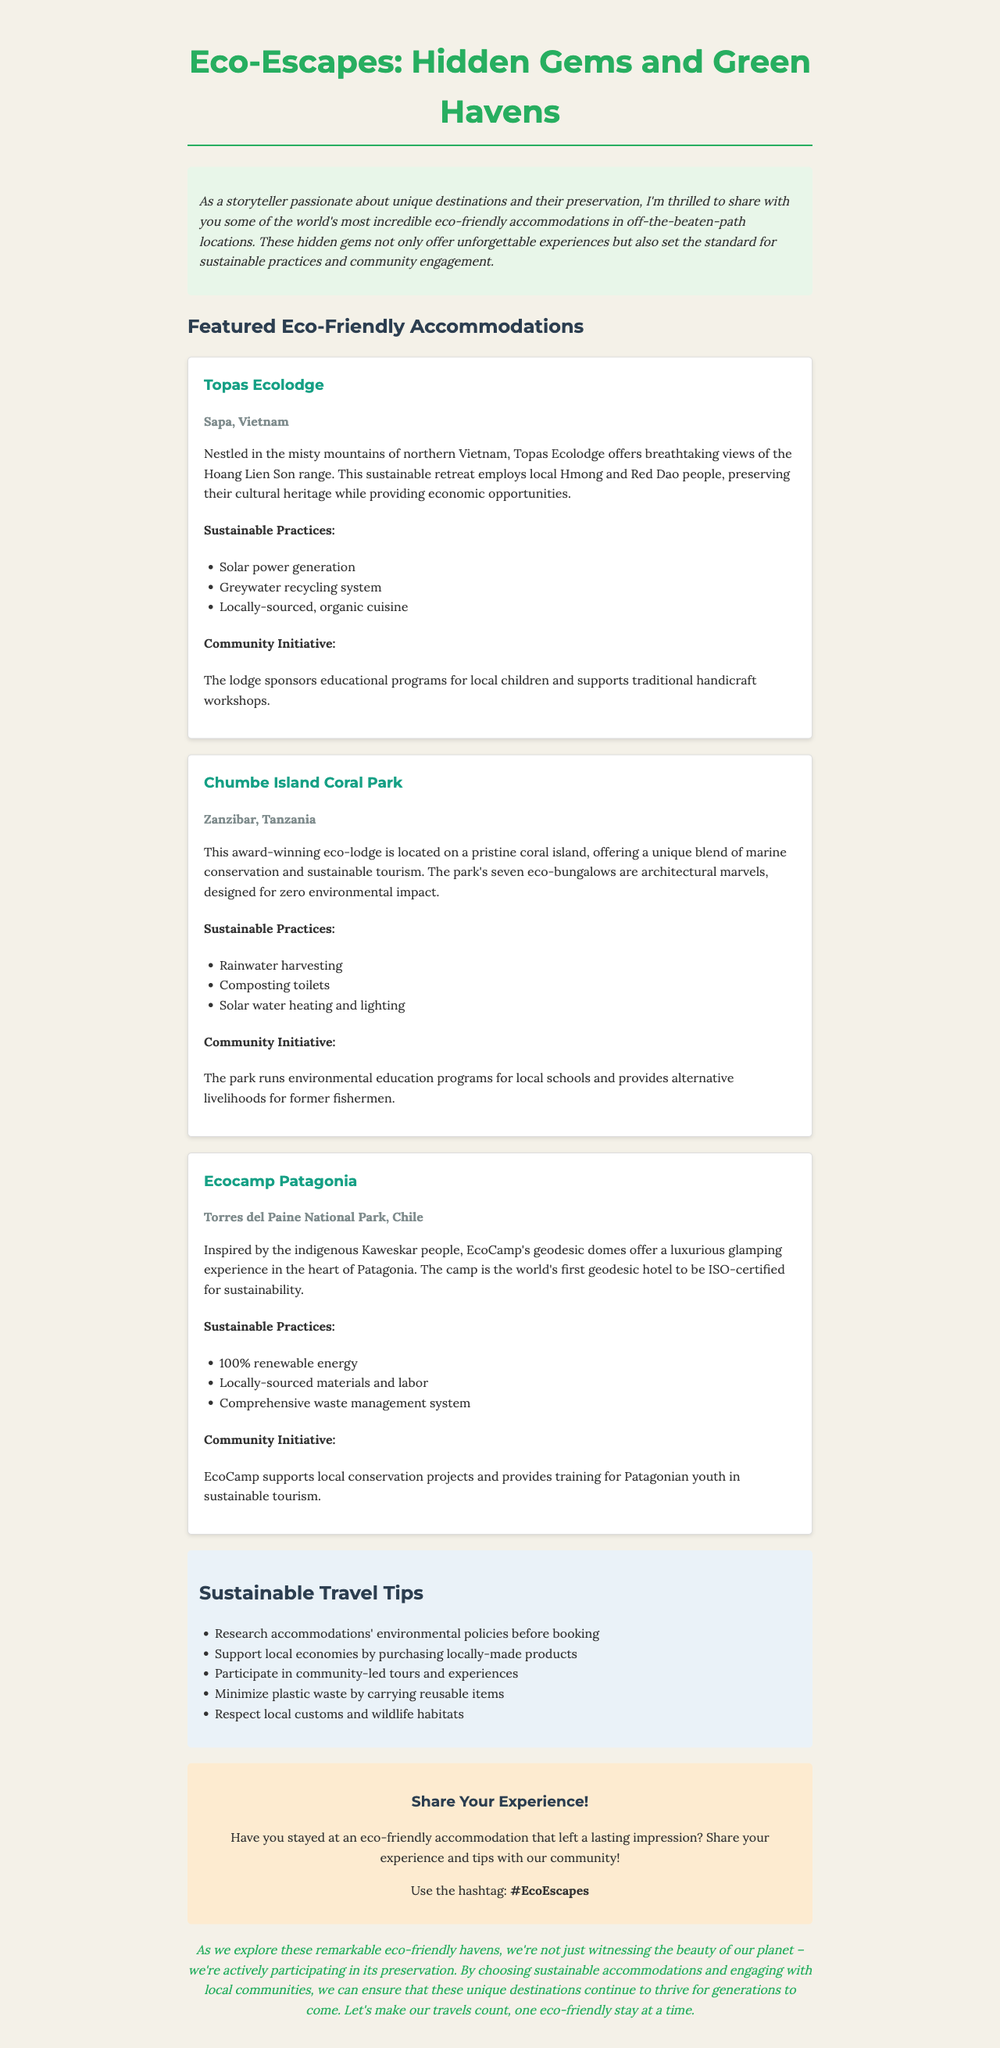what is the newsletter title? The newsletter title is stated at the beginning of the document as a heading.
Answer: Eco-Escapes: Hidden Gems and Green Havens where is Topas Ecolodge located? Topas Ecolodge's location is provided in the accommodation section of the document.
Answer: Sapa, Vietnam how many eco-bungalows are at Chumbe Island Coral Park? The number of eco-bungalows is mentioned in the description of Chumbe Island Coral Park.
Answer: Seven what sustainable practice involves collecting water? The sustainable practice related to collecting water is specified in Chumbe Island Coral Park.
Answer: Rainwater harvesting what community initiative does EcoCamp support? The community initiative supported by EcoCamp is outlined under the featured accommodations.
Answer: Local conservation projects which accommodation is the first geodesic hotel to be ISO-certified for sustainability? The document states the unique feature of EcoCamp in comparison to other accommodations.
Answer: EcoCamp Patagonia what is one tip for sustainable travel mentioned in the newsletter? One of the travel tips is listed in a dedicated section about sustainable practices.
Answer: Minimize plastic waste by carrying reusable items what is the primary purpose of this newsletter? The overall aim of the newsletter is described in the introduction section.
Answer: To shed light on unique eco-friendly destinations and their preservation who should share their experiences with the hashtag #EcoEscapes? This question pertains to reader engagement, which is highlighted towards the end of the document.
Answer: Readers who have stayed at an eco-friendly accommodation 